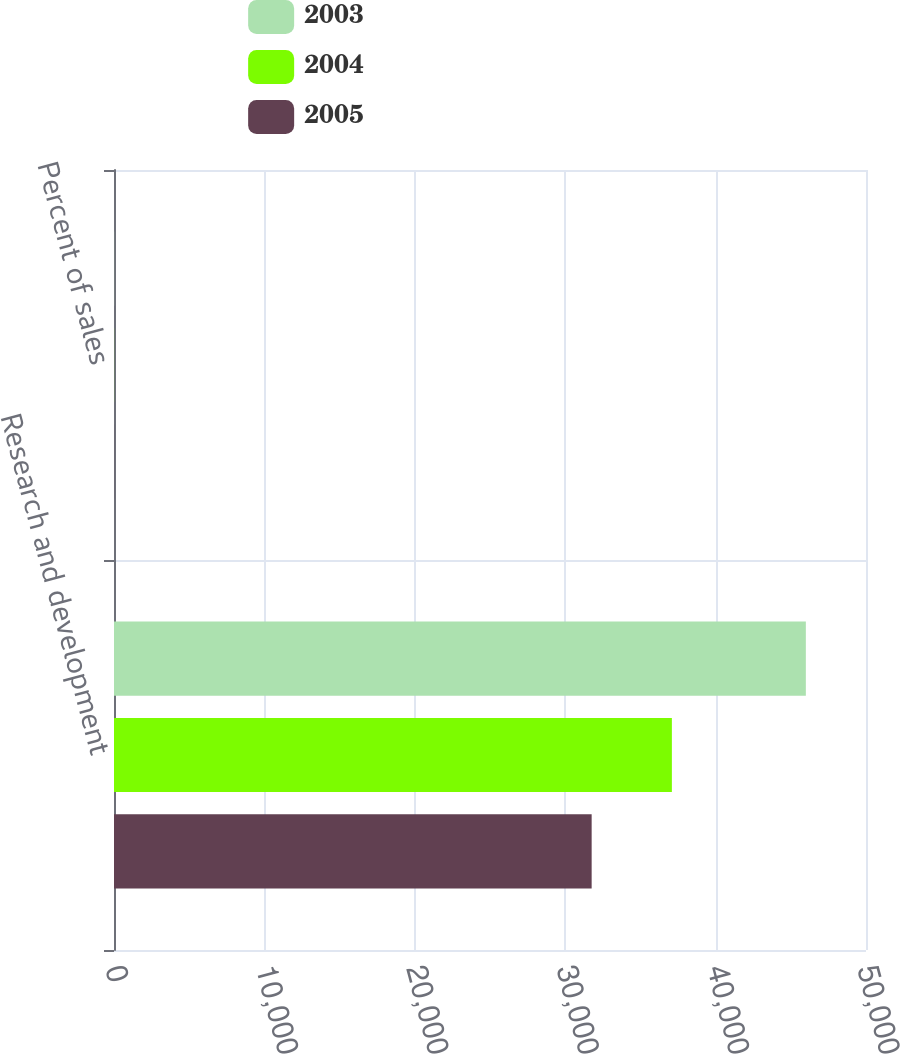<chart> <loc_0><loc_0><loc_500><loc_500><stacked_bar_chart><ecel><fcel>Research and development<fcel>Percent of sales<nl><fcel>2003<fcel>46000<fcel>6.6<nl><fcel>2004<fcel>37093<fcel>5.6<nl><fcel>2005<fcel>31759<fcel>5.9<nl></chart> 